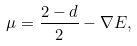<formula> <loc_0><loc_0><loc_500><loc_500>\mu = \frac { 2 - d } { 2 } - \nabla E ,</formula> 